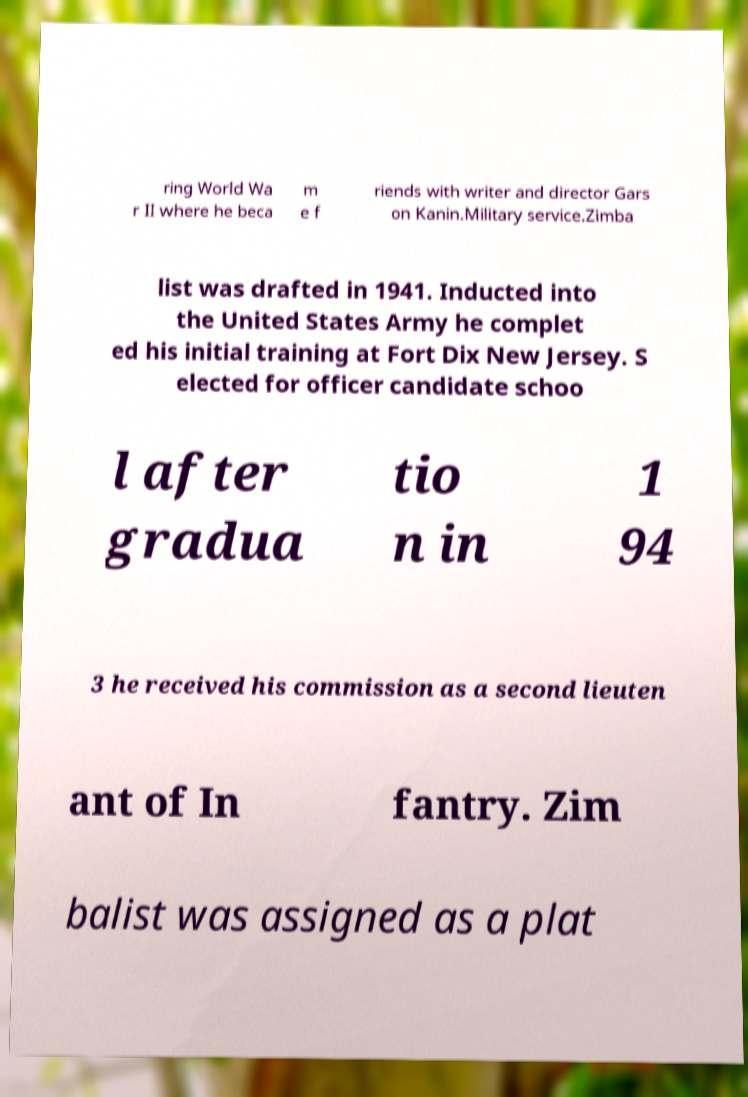For documentation purposes, I need the text within this image transcribed. Could you provide that? ring World Wa r II where he beca m e f riends with writer and director Gars on Kanin.Military service.Zimba list was drafted in 1941. Inducted into the United States Army he complet ed his initial training at Fort Dix New Jersey. S elected for officer candidate schoo l after gradua tio n in 1 94 3 he received his commission as a second lieuten ant of In fantry. Zim balist was assigned as a plat 